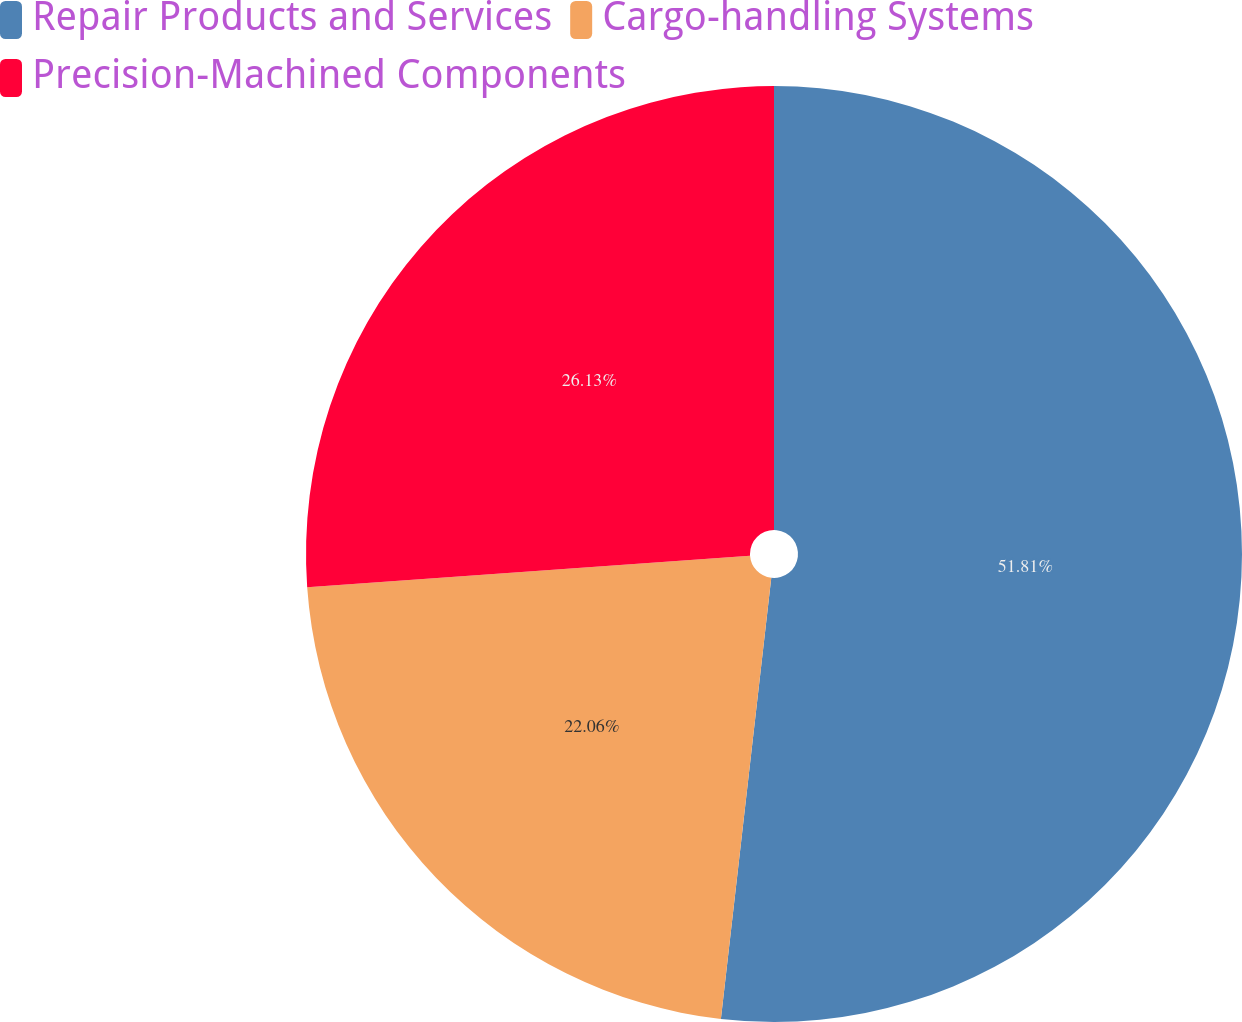<chart> <loc_0><loc_0><loc_500><loc_500><pie_chart><fcel>Repair Products and Services<fcel>Cargo-handling Systems<fcel>Precision-Machined Components<nl><fcel>51.81%<fcel>22.06%<fcel>26.13%<nl></chart> 